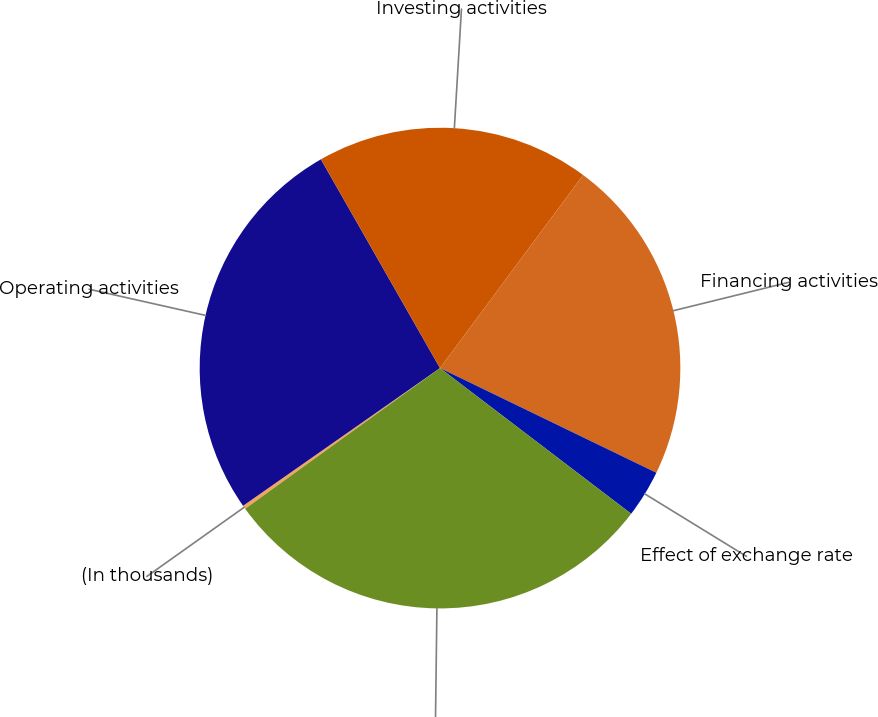Convert chart to OTSL. <chart><loc_0><loc_0><loc_500><loc_500><pie_chart><fcel>(In thousands)<fcel>Operating activities<fcel>Investing activities<fcel>Financing activities<fcel>Effect of exchange rate<fcel>Net increase (decrease) in<nl><fcel>0.24%<fcel>26.46%<fcel>18.4%<fcel>22.02%<fcel>3.19%<fcel>29.68%<nl></chart> 